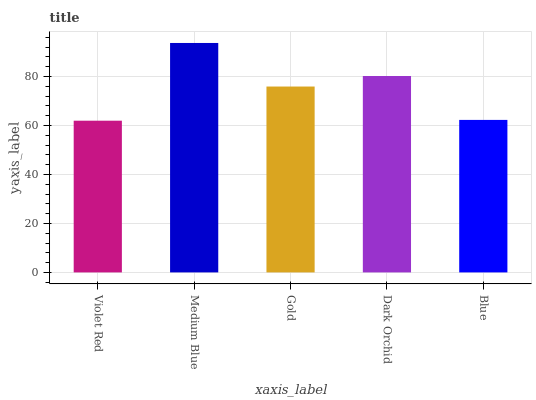Is Gold the minimum?
Answer yes or no. No. Is Gold the maximum?
Answer yes or no. No. Is Medium Blue greater than Gold?
Answer yes or no. Yes. Is Gold less than Medium Blue?
Answer yes or no. Yes. Is Gold greater than Medium Blue?
Answer yes or no. No. Is Medium Blue less than Gold?
Answer yes or no. No. Is Gold the high median?
Answer yes or no. Yes. Is Gold the low median?
Answer yes or no. Yes. Is Violet Red the high median?
Answer yes or no. No. Is Blue the low median?
Answer yes or no. No. 